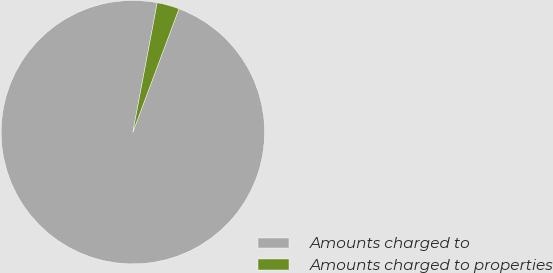Convert chart to OTSL. <chart><loc_0><loc_0><loc_500><loc_500><pie_chart><fcel>Amounts charged to<fcel>Amounts charged to properties<nl><fcel>97.27%<fcel>2.73%<nl></chart> 